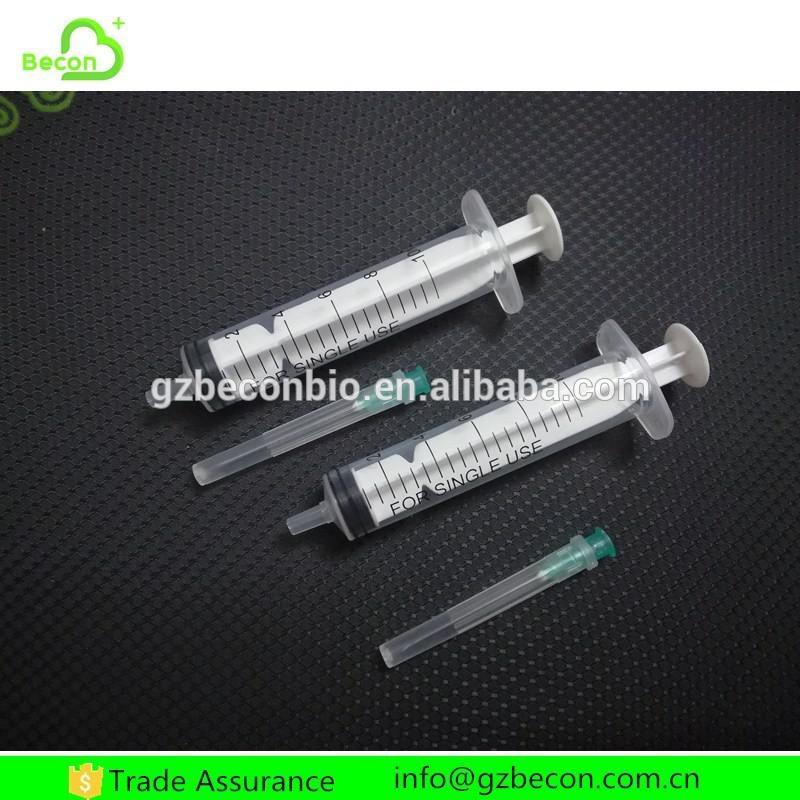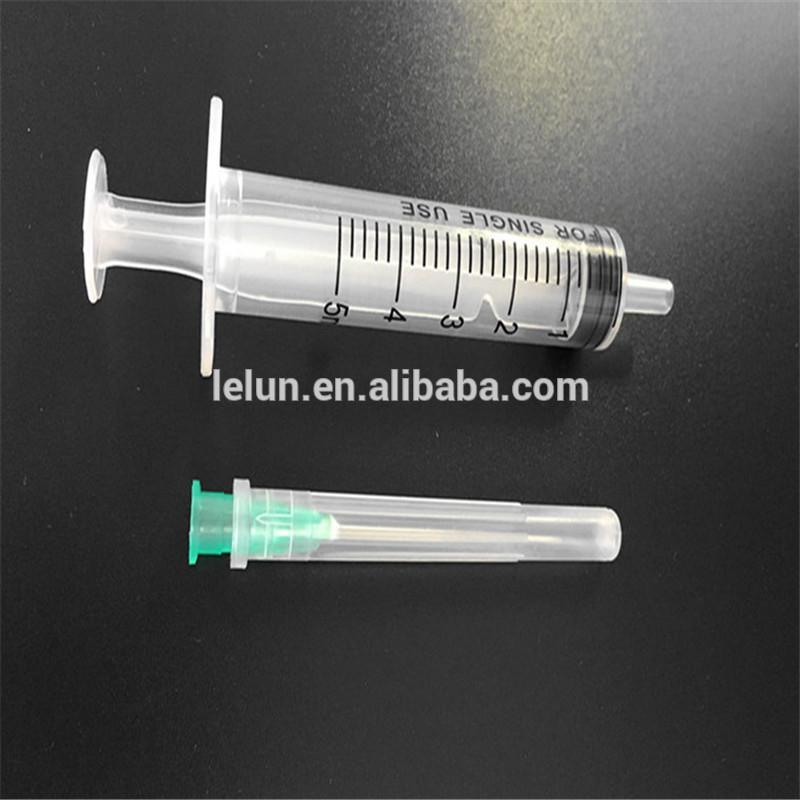The first image is the image on the left, the second image is the image on the right. Assess this claim about the two images: "At least one of the images has exactly three syringes.". Correct or not? Answer yes or no. No. The first image is the image on the left, the second image is the image on the right. Assess this claim about the two images: "An image shows exactly two syringe-related items displayed horizontally.". Correct or not? Answer yes or no. Yes. 